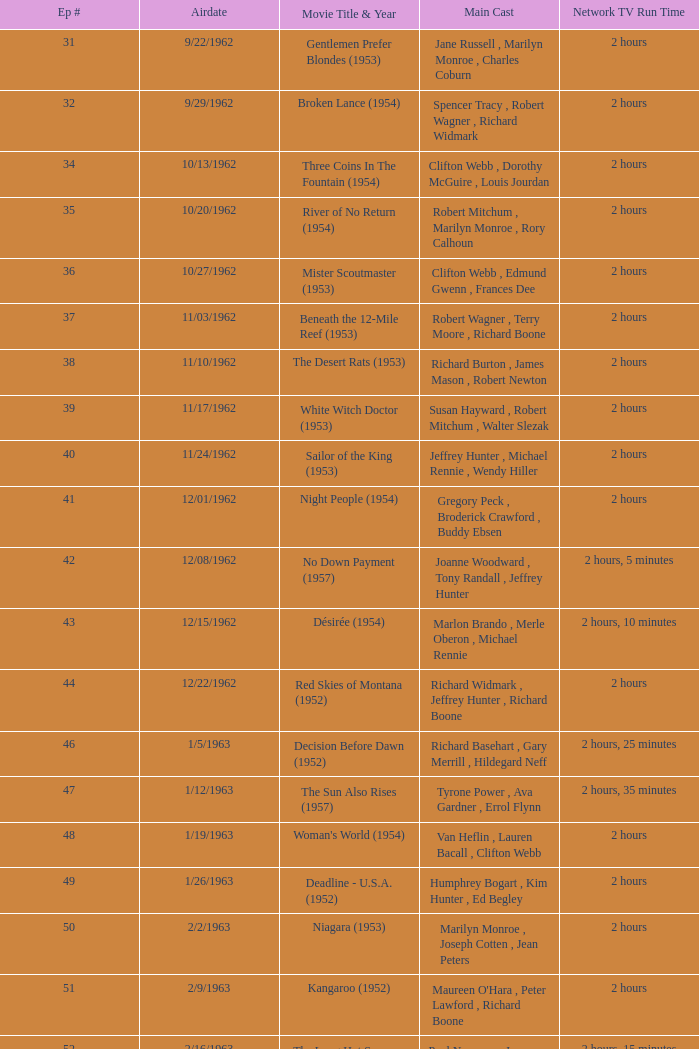What movie did dana wynter , mel ferrer , theodore bikel star in? Fraulein (1958). 